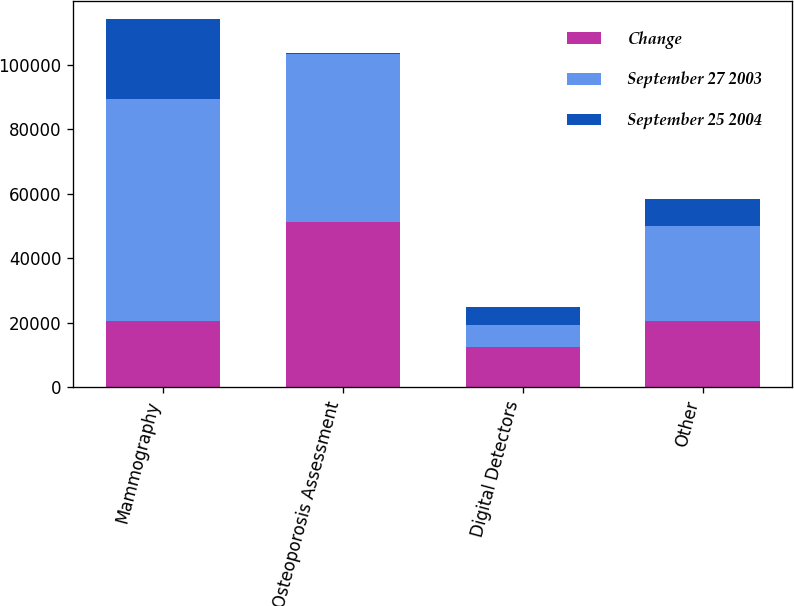Convert chart to OTSL. <chart><loc_0><loc_0><loc_500><loc_500><stacked_bar_chart><ecel><fcel>Mammography<fcel>Osteoporosis Assessment<fcel>Digital Detectors<fcel>Other<nl><fcel>Change<fcel>20654<fcel>51376<fcel>12370<fcel>20654<nl><fcel>September 27 2003<fcel>68739<fcel>51900<fcel>6843<fcel>29252<nl><fcel>September 25 2004<fcel>24797<fcel>524<fcel>5527<fcel>8598<nl></chart> 